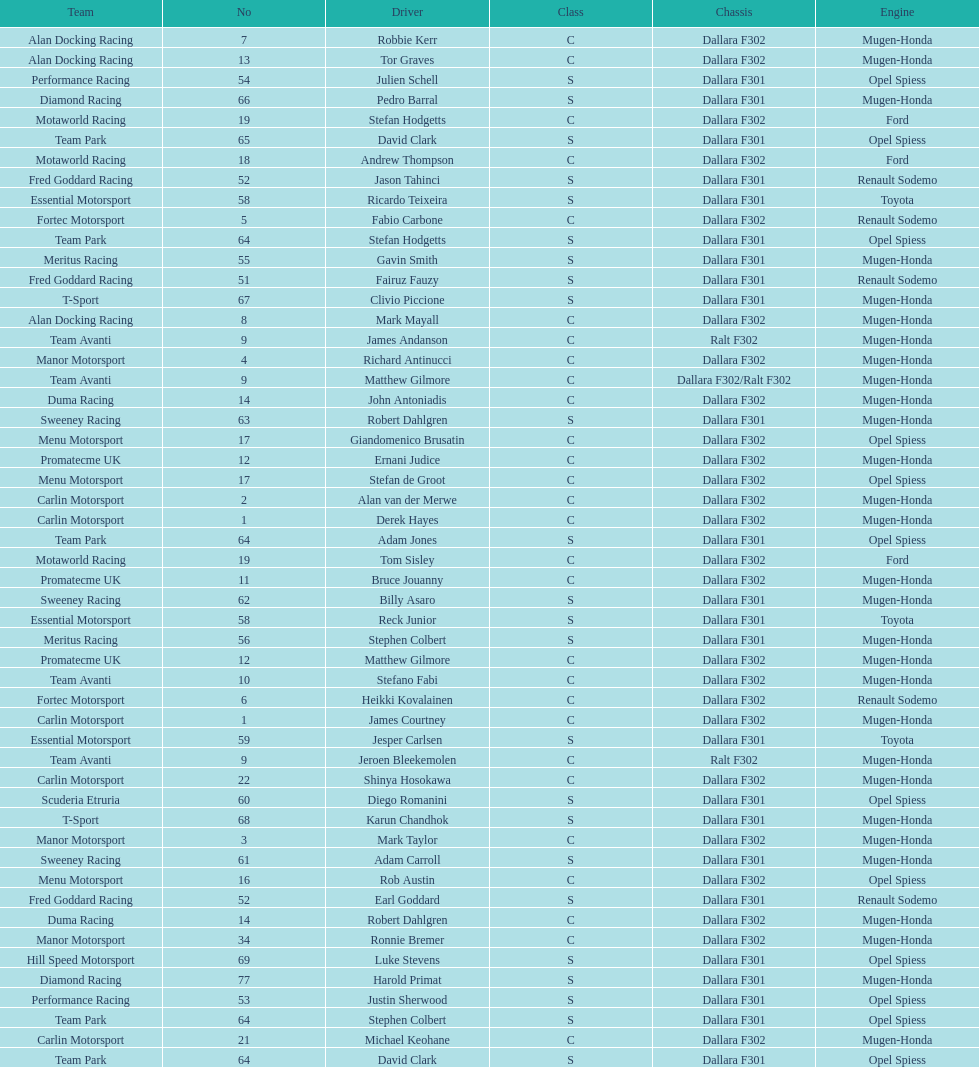Would you be able to parse every entry in this table? {'header': ['Team', 'No', 'Driver', 'Class', 'Chassis', 'Engine'], 'rows': [['Alan Docking Racing', '7', 'Robbie Kerr', 'C', 'Dallara F302', 'Mugen-Honda'], ['Alan Docking Racing', '13', 'Tor Graves', 'C', 'Dallara F302', 'Mugen-Honda'], ['Performance Racing', '54', 'Julien Schell', 'S', 'Dallara F301', 'Opel Spiess'], ['Diamond Racing', '66', 'Pedro Barral', 'S', 'Dallara F301', 'Mugen-Honda'], ['Motaworld Racing', '19', 'Stefan Hodgetts', 'C', 'Dallara F302', 'Ford'], ['Team Park', '65', 'David Clark', 'S', 'Dallara F301', 'Opel Spiess'], ['Motaworld Racing', '18', 'Andrew Thompson', 'C', 'Dallara F302', 'Ford'], ['Fred Goddard Racing', '52', 'Jason Tahinci', 'S', 'Dallara F301', 'Renault Sodemo'], ['Essential Motorsport', '58', 'Ricardo Teixeira', 'S', 'Dallara F301', 'Toyota'], ['Fortec Motorsport', '5', 'Fabio Carbone', 'C', 'Dallara F302', 'Renault Sodemo'], ['Team Park', '64', 'Stefan Hodgetts', 'S', 'Dallara F301', 'Opel Spiess'], ['Meritus Racing', '55', 'Gavin Smith', 'S', 'Dallara F301', 'Mugen-Honda'], ['Fred Goddard Racing', '51', 'Fairuz Fauzy', 'S', 'Dallara F301', 'Renault Sodemo'], ['T-Sport', '67', 'Clivio Piccione', 'S', 'Dallara F301', 'Mugen-Honda'], ['Alan Docking Racing', '8', 'Mark Mayall', 'C', 'Dallara F302', 'Mugen-Honda'], ['Team Avanti', '9', 'James Andanson', 'C', 'Ralt F302', 'Mugen-Honda'], ['Manor Motorsport', '4', 'Richard Antinucci', 'C', 'Dallara F302', 'Mugen-Honda'], ['Team Avanti', '9', 'Matthew Gilmore', 'C', 'Dallara F302/Ralt F302', 'Mugen-Honda'], ['Duma Racing', '14', 'John Antoniadis', 'C', 'Dallara F302', 'Mugen-Honda'], ['Sweeney Racing', '63', 'Robert Dahlgren', 'S', 'Dallara F301', 'Mugen-Honda'], ['Menu Motorsport', '17', 'Giandomenico Brusatin', 'C', 'Dallara F302', 'Opel Spiess'], ['Promatecme UK', '12', 'Ernani Judice', 'C', 'Dallara F302', 'Mugen-Honda'], ['Menu Motorsport', '17', 'Stefan de Groot', 'C', 'Dallara F302', 'Opel Spiess'], ['Carlin Motorsport', '2', 'Alan van der Merwe', 'C', 'Dallara F302', 'Mugen-Honda'], ['Carlin Motorsport', '1', 'Derek Hayes', 'C', 'Dallara F302', 'Mugen-Honda'], ['Team Park', '64', 'Adam Jones', 'S', 'Dallara F301', 'Opel Spiess'], ['Motaworld Racing', '19', 'Tom Sisley', 'C', 'Dallara F302', 'Ford'], ['Promatecme UK', '11', 'Bruce Jouanny', 'C', 'Dallara F302', 'Mugen-Honda'], ['Sweeney Racing', '62', 'Billy Asaro', 'S', 'Dallara F301', 'Mugen-Honda'], ['Essential Motorsport', '58', 'Reck Junior', 'S', 'Dallara F301', 'Toyota'], ['Meritus Racing', '56', 'Stephen Colbert', 'S', 'Dallara F301', 'Mugen-Honda'], ['Promatecme UK', '12', 'Matthew Gilmore', 'C', 'Dallara F302', 'Mugen-Honda'], ['Team Avanti', '10', 'Stefano Fabi', 'C', 'Dallara F302', 'Mugen-Honda'], ['Fortec Motorsport', '6', 'Heikki Kovalainen', 'C', 'Dallara F302', 'Renault Sodemo'], ['Carlin Motorsport', '1', 'James Courtney', 'C', 'Dallara F302', 'Mugen-Honda'], ['Essential Motorsport', '59', 'Jesper Carlsen', 'S', 'Dallara F301', 'Toyota'], ['Team Avanti', '9', 'Jeroen Bleekemolen', 'C', 'Ralt F302', 'Mugen-Honda'], ['Carlin Motorsport', '22', 'Shinya Hosokawa', 'C', 'Dallara F302', 'Mugen-Honda'], ['Scuderia Etruria', '60', 'Diego Romanini', 'S', 'Dallara F301', 'Opel Spiess'], ['T-Sport', '68', 'Karun Chandhok', 'S', 'Dallara F301', 'Mugen-Honda'], ['Manor Motorsport', '3', 'Mark Taylor', 'C', 'Dallara F302', 'Mugen-Honda'], ['Sweeney Racing', '61', 'Adam Carroll', 'S', 'Dallara F301', 'Mugen-Honda'], ['Menu Motorsport', '16', 'Rob Austin', 'C', 'Dallara F302', 'Opel Spiess'], ['Fred Goddard Racing', '52', 'Earl Goddard', 'S', 'Dallara F301', 'Renault Sodemo'], ['Duma Racing', '14', 'Robert Dahlgren', 'C', 'Dallara F302', 'Mugen-Honda'], ['Manor Motorsport', '34', 'Ronnie Bremer', 'C', 'Dallara F302', 'Mugen-Honda'], ['Hill Speed Motorsport', '69', 'Luke Stevens', 'S', 'Dallara F301', 'Opel Spiess'], ['Diamond Racing', '77', 'Harold Primat', 'S', 'Dallara F301', 'Mugen-Honda'], ['Performance Racing', '53', 'Justin Sherwood', 'S', 'Dallara F301', 'Opel Spiess'], ['Team Park', '64', 'Stephen Colbert', 'S', 'Dallara F301', 'Opel Spiess'], ['Carlin Motorsport', '21', 'Michael Keohane', 'C', 'Dallara F302', 'Mugen-Honda'], ['Team Park', '64', 'David Clark', 'S', 'Dallara F301', 'Opel Spiess']]} How many teams had at least two drivers this season? 17. 